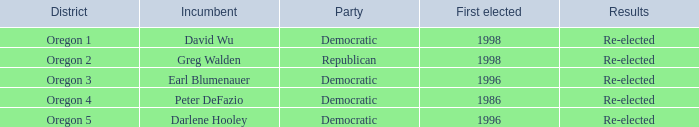Which district has a Democratic incumbent that was first elected before 1996? Oregon 4. 